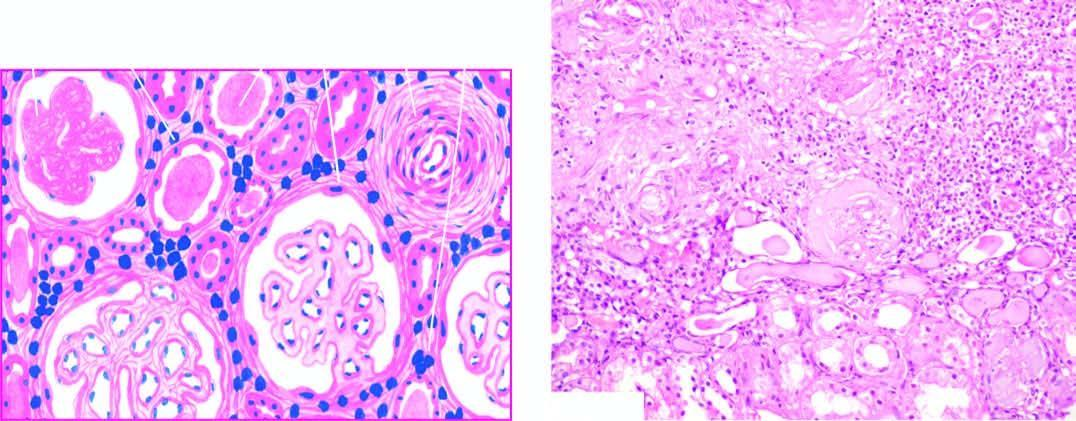re the tubules surrounded by abundant fibrous tissue and chronic interstitial inflammatory reaction?
Answer the question using a single word or phrase. Yes 